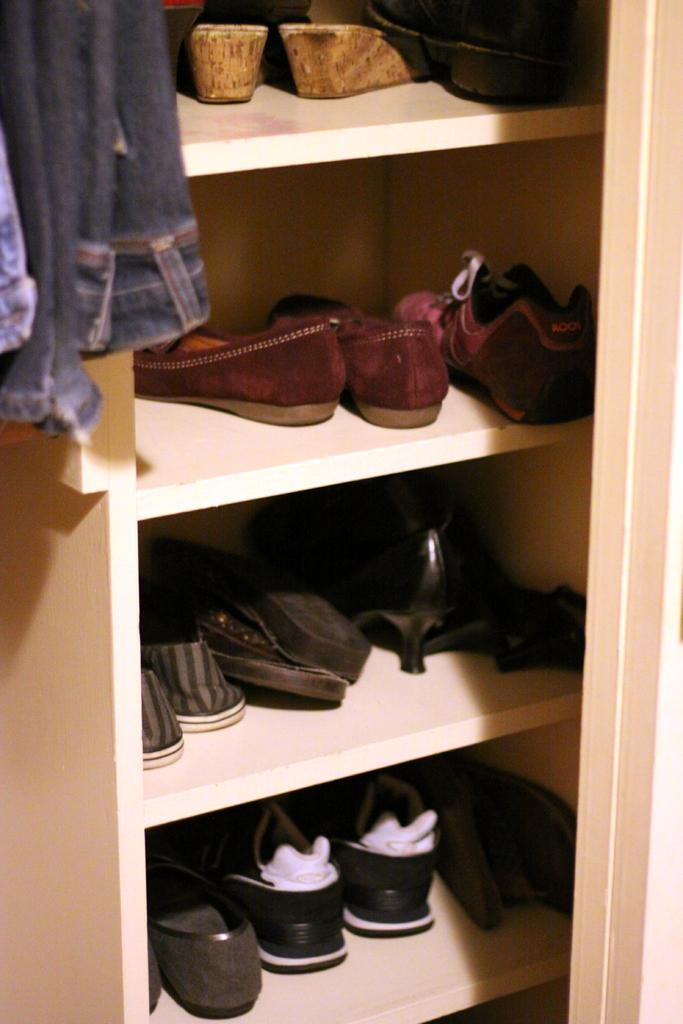What is on the rack in the image? There is footwear on a rack in the image. What else can be seen in the image besides the footwear? There are clothes in the image. Did the earthquake cause the footwear to fall off the rack in the image? There is no indication of an earthquake or any fallen footwear in the image. 